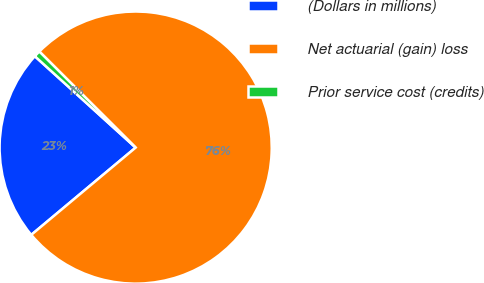Convert chart. <chart><loc_0><loc_0><loc_500><loc_500><pie_chart><fcel>(Dollars in millions)<fcel>Net actuarial (gain) loss<fcel>Prior service cost (credits)<nl><fcel>22.8%<fcel>76.44%<fcel>0.76%<nl></chart> 